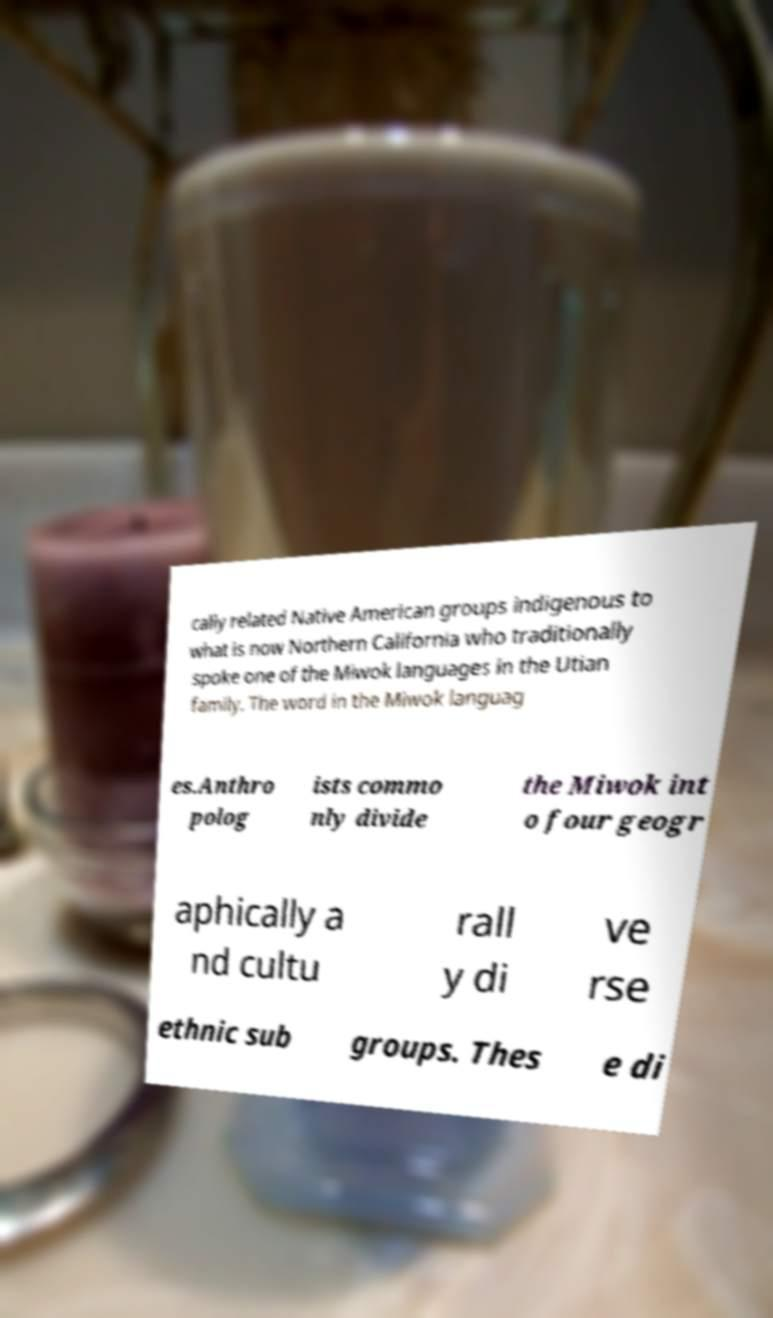For documentation purposes, I need the text within this image transcribed. Could you provide that? cally related Native American groups indigenous to what is now Northern California who traditionally spoke one of the Miwok languages in the Utian family. The word in the Miwok languag es.Anthro polog ists commo nly divide the Miwok int o four geogr aphically a nd cultu rall y di ve rse ethnic sub groups. Thes e di 